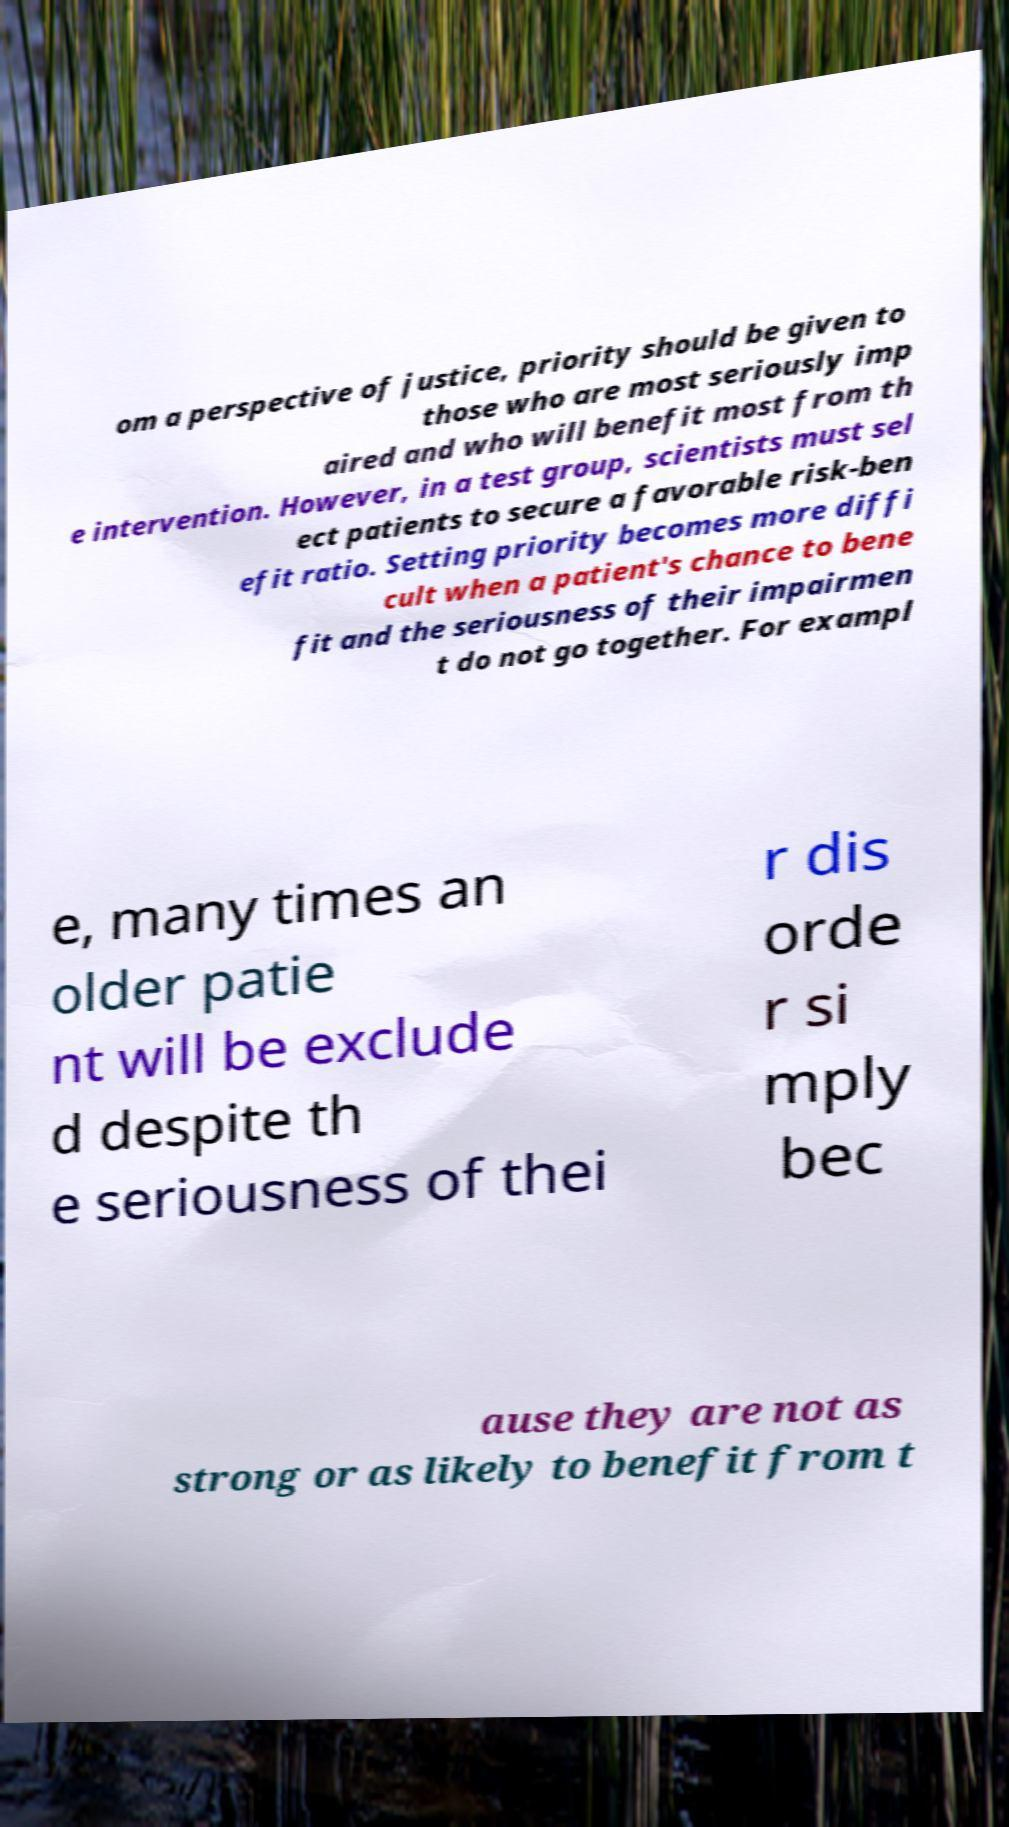For documentation purposes, I need the text within this image transcribed. Could you provide that? om a perspective of justice, priority should be given to those who are most seriously imp aired and who will benefit most from th e intervention. However, in a test group, scientists must sel ect patients to secure a favorable risk-ben efit ratio. Setting priority becomes more diffi cult when a patient's chance to bene fit and the seriousness of their impairmen t do not go together. For exampl e, many times an older patie nt will be exclude d despite th e seriousness of thei r dis orde r si mply bec ause they are not as strong or as likely to benefit from t 